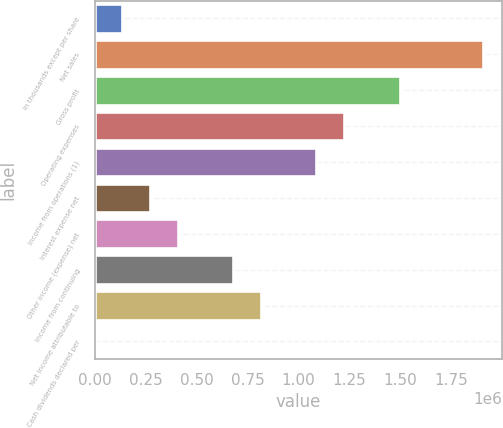Convert chart to OTSL. <chart><loc_0><loc_0><loc_500><loc_500><bar_chart><fcel>In thousands except per share<fcel>Net sales<fcel>Gross profit<fcel>Operating expenses<fcel>Income from operations (1)<fcel>Interest expense net<fcel>Other income (expense) net<fcel>Income from continuing<fcel>Net income attributable to<fcel>Cash dividends declared per<nl><fcel>136009<fcel>1.90412e+06<fcel>1.4961e+06<fcel>1.22408e+06<fcel>1.08807e+06<fcel>272018<fcel>408026<fcel>680044<fcel>816053<fcel>0.04<nl></chart> 